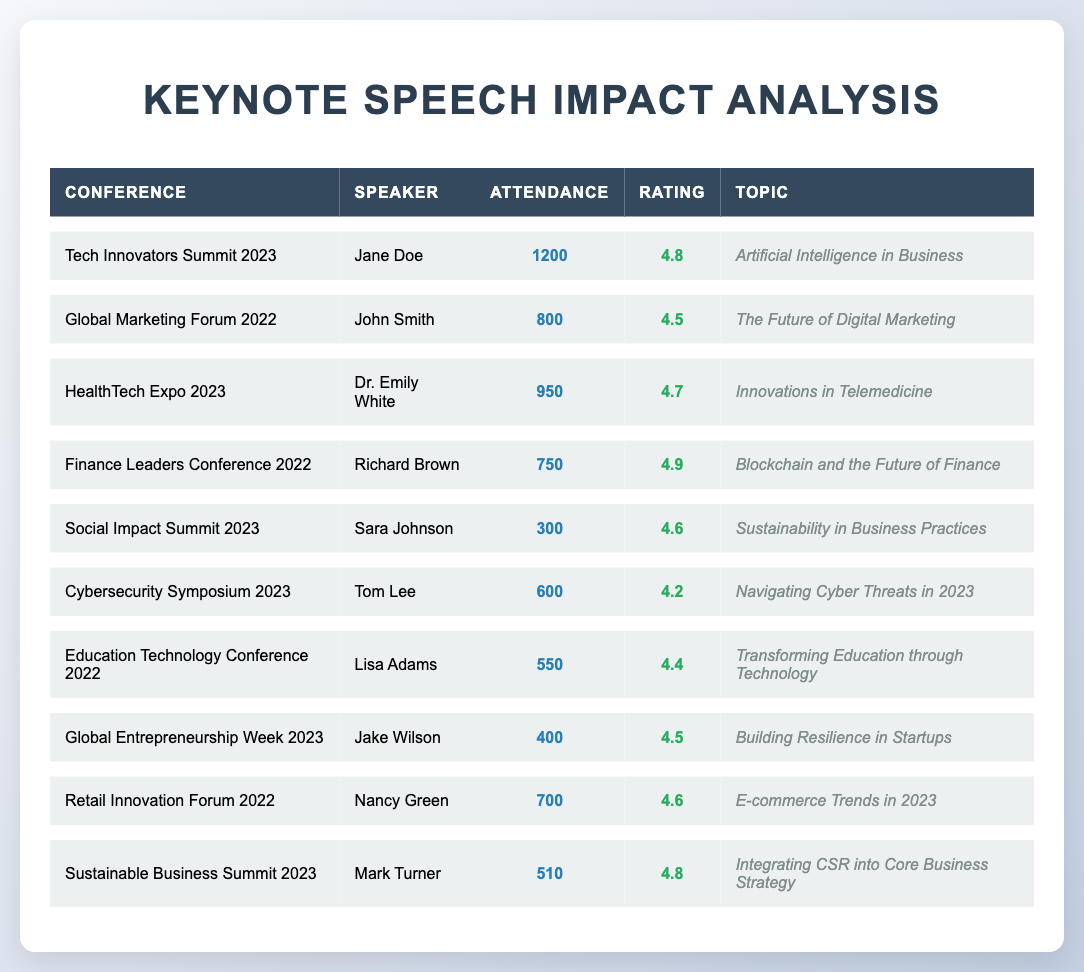What was the attendance at the Tech Innovators Summit 2023? The attendance for the Tech Innovators Summit 2023 is listed directly in the table. It shows a value of 1200 for this conference.
Answer: 1200 Who had the highest feedback rating among the speakers? The highest feedback rating in the table is noted as 4.9 for Richard Brown at the Finance Leaders Conference 2022.
Answer: Richard Brown How many attendees were there in total for the Sustainable Business Summit 2023? The table states that the attendance for the Sustainable Business Summit 2023 is 510, which is directly retrieved from the table.
Answer: 510 What is the average feedback rating of all the keynote speeches listed? To find the average, we add all the feedback ratings: 4.8 + 4.5 + 4.7 + 4.9 + 4.6 + 4.2 + 4.4 + 4.5 + 4.6 + 4.8 = 46.0. There are 10 speeches, so the average is 46.0 / 10 = 4.6.
Answer: 4.6 Did any speaker have an attendance of over 1000 participants? Checking the attendance figures in the table reveals that only the Tech Innovators Summit 2023 has attendance over 1000, specifically 1200, confirming that at least one speaker did indeed have more than 1000 attendees.
Answer: Yes Which topic had the lowest attendance and what was that attendance? From the table, the lowest attendance is seen at the Social Impact Summit 2023 with 300 attendees. This value can be found in the attendance column.
Answer: 300 How many speeches had a feedback rating of 4.6 or higher? We can scan through the feedback ratings in the table. The ratings 4.8, 4.7, 4.9, 4.6, 4.6, 4.8 are all 4.6 or higher, making a total of 6 speeches out of 10.
Answer: 6 What is the difference in attendance between the highest and lowest attended speeches? The highest attendance is 1200 (Tech Innovators Summit 2023) and the lowest is 300 (Social Impact Summit 2023). The difference is calculated as 1200 - 300 = 900.
Answer: 900 Which topics had feedback ratings less than 4.5? The only topic with a feedback rating less than 4.5 is "Navigating Cyber Threats in 2023" by Tom Lee, who has a rating of 4.2. This is determined by checking each rating against 4.5.
Answer: Navigating Cyber Threats in 2023 How does the attendance of the HealthTech Expo 2023 compare to the Global Entrepreneurship Week 2023? The attendance for HealthTech Expo is 950, while Global Entrepreneurship Week is 400. Thus, HealthTech Expo had 950 - 400 = 550 more attendees than Global Entrepreneurship Week.
Answer: 550 more attendees 